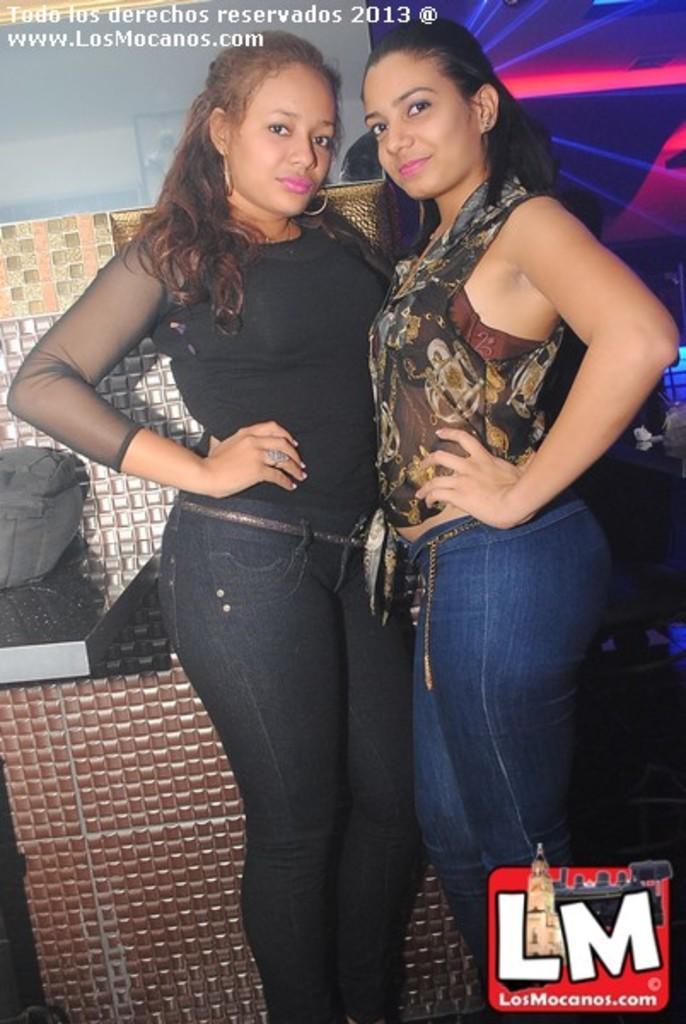Can you describe this image briefly? In this image I can see two women standing and wearing different color dress. Back I can see different color background. 